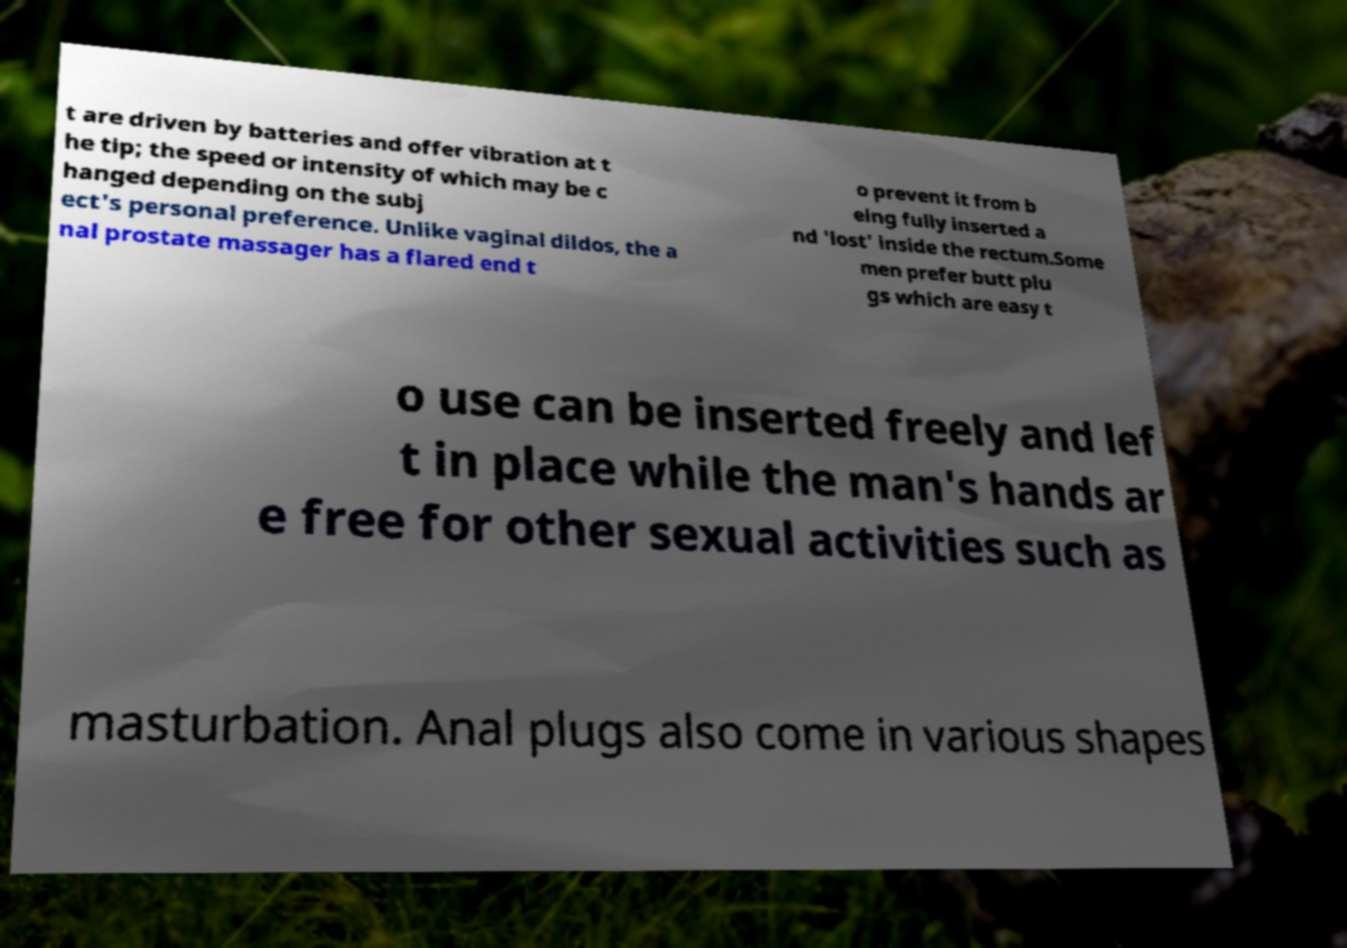Please read and relay the text visible in this image. What does it say? t are driven by batteries and offer vibration at t he tip; the speed or intensity of which may be c hanged depending on the subj ect's personal preference. Unlike vaginal dildos, the a nal prostate massager has a flared end t o prevent it from b eing fully inserted a nd 'lost' inside the rectum.Some men prefer butt plu gs which are easy t o use can be inserted freely and lef t in place while the man's hands ar e free for other sexual activities such as masturbation. Anal plugs also come in various shapes 